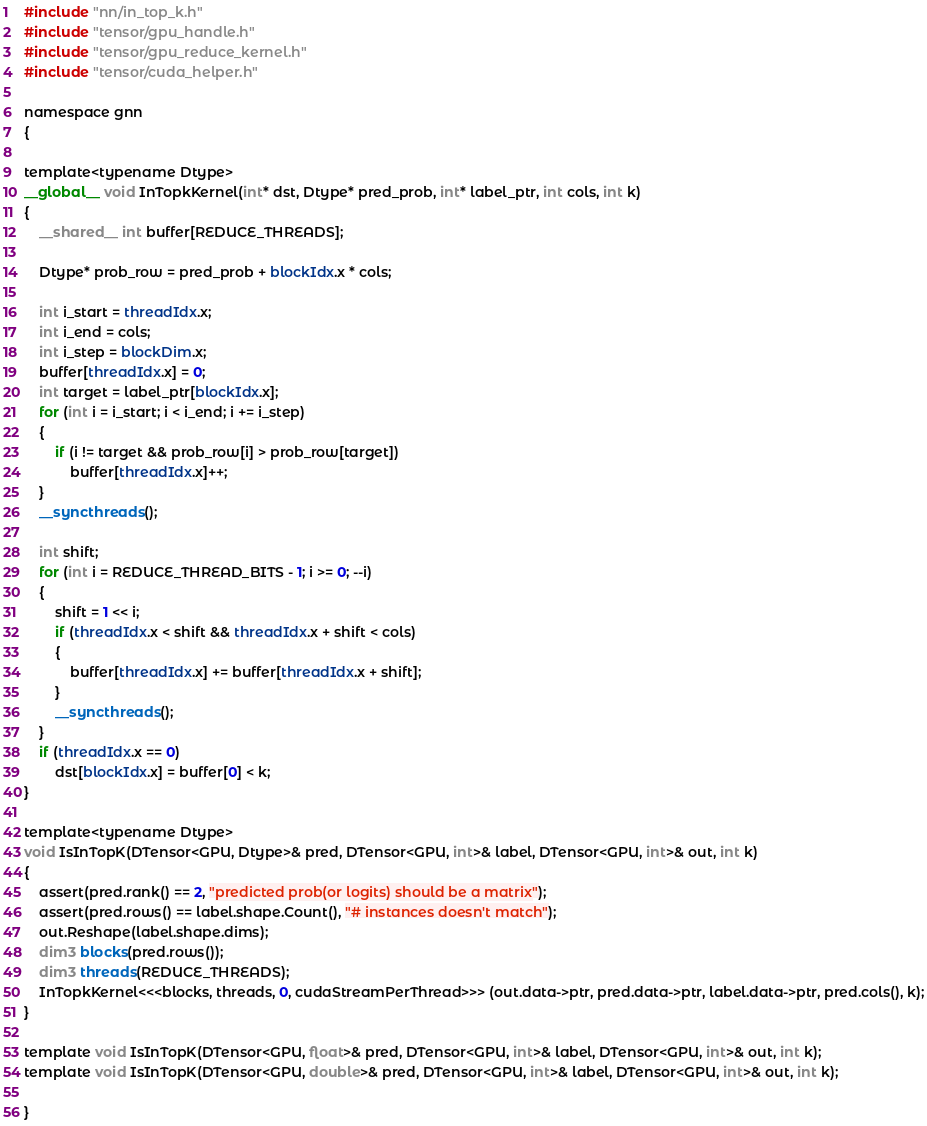Convert code to text. <code><loc_0><loc_0><loc_500><loc_500><_Cuda_>#include "nn/in_top_k.h"
#include "tensor/gpu_handle.h"
#include "tensor/gpu_reduce_kernel.h"
#include "tensor/cuda_helper.h"

namespace gnn
{

template<typename Dtype>
__global__ void InTopkKernel(int* dst, Dtype* pred_prob, int* label_ptr, int cols, int k)
{
    __shared__ int buffer[REDUCE_THREADS];

    Dtype* prob_row = pred_prob + blockIdx.x * cols;

    int i_start = threadIdx.x;
    int i_end = cols;
    int i_step = blockDim.x;    
    buffer[threadIdx.x] = 0;
    int target = label_ptr[blockIdx.x];
    for (int i = i_start; i < i_end; i += i_step)
    {
    	if (i != target && prob_row[i] > prob_row[target])
    		buffer[threadIdx.x]++;
    }
    __syncthreads();

    int shift;
    for (int i = REDUCE_THREAD_BITS - 1; i >= 0; --i)
    {
    	shift = 1 << i;
    	if (threadIdx.x < shift && threadIdx.x + shift < cols)
    	{
    		buffer[threadIdx.x] += buffer[threadIdx.x + shift];
    	}
		__syncthreads();
    }
    if (threadIdx.x == 0)
    	dst[blockIdx.x] = buffer[0] < k;
}

template<typename Dtype>
void IsInTopK(DTensor<GPU, Dtype>& pred, DTensor<GPU, int>& label, DTensor<GPU, int>& out, int k)
{
	assert(pred.rank() == 2, "predicted prob(or logits) should be a matrix");
	assert(pred.rows() == label.shape.Count(), "# instances doesn't match");
	out.Reshape(label.shape.dims);
	dim3 blocks(pred.rows());
	dim3 threads(REDUCE_THREADS);
    InTopkKernel<<<blocks, threads, 0, cudaStreamPerThread>>> (out.data->ptr, pred.data->ptr, label.data->ptr, pred.cols(), k);
}

template void IsInTopK(DTensor<GPU, float>& pred, DTensor<GPU, int>& label, DTensor<GPU, int>& out, int k);
template void IsInTopK(DTensor<GPU, double>& pred, DTensor<GPU, int>& label, DTensor<GPU, int>& out, int k);

}</code> 